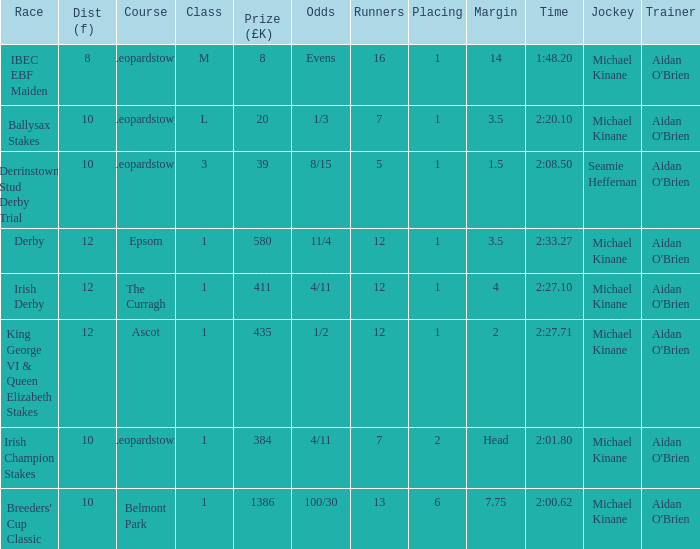Name the highest Dist (f) with Odds of 11/4 and a Placing larger than 1? None. 